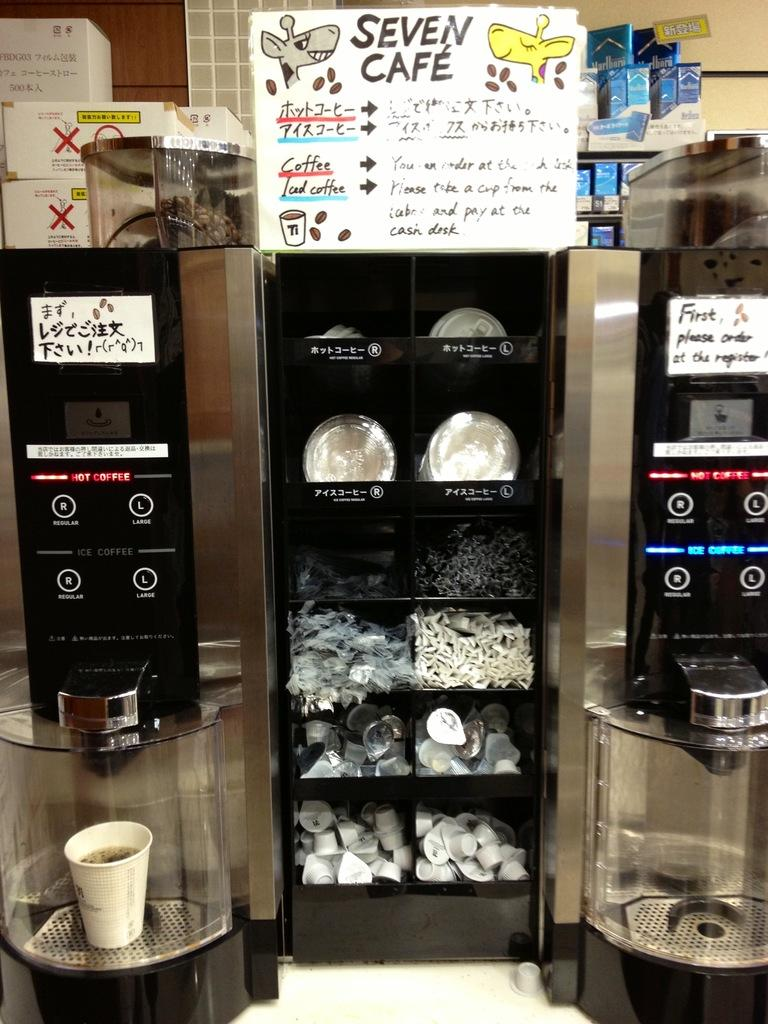<image>
Provide a brief description of the given image. A shelving unit with coffee lids, creamers, utensils in between two coffee machines at Seven Cafe. 